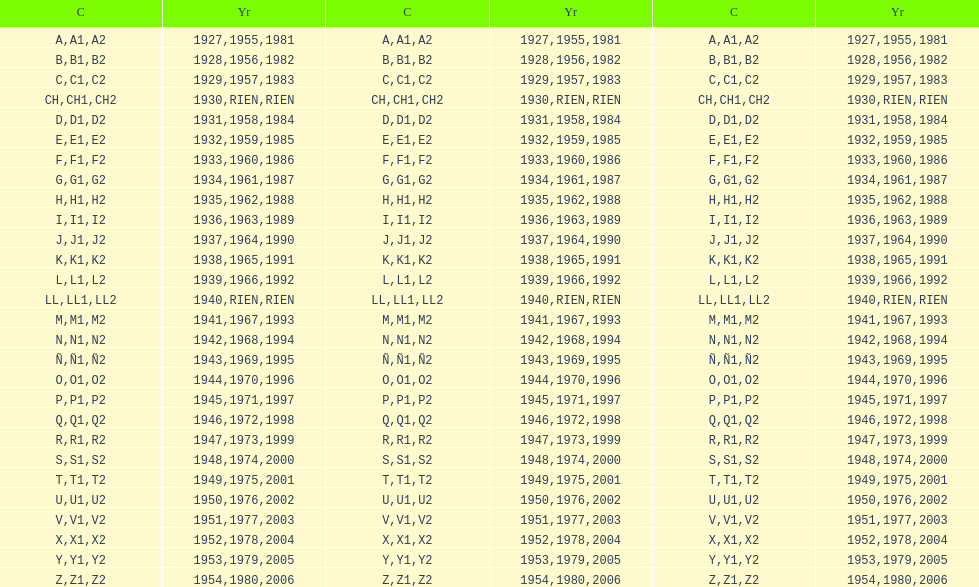Is the e-code below 1950? Yes. 